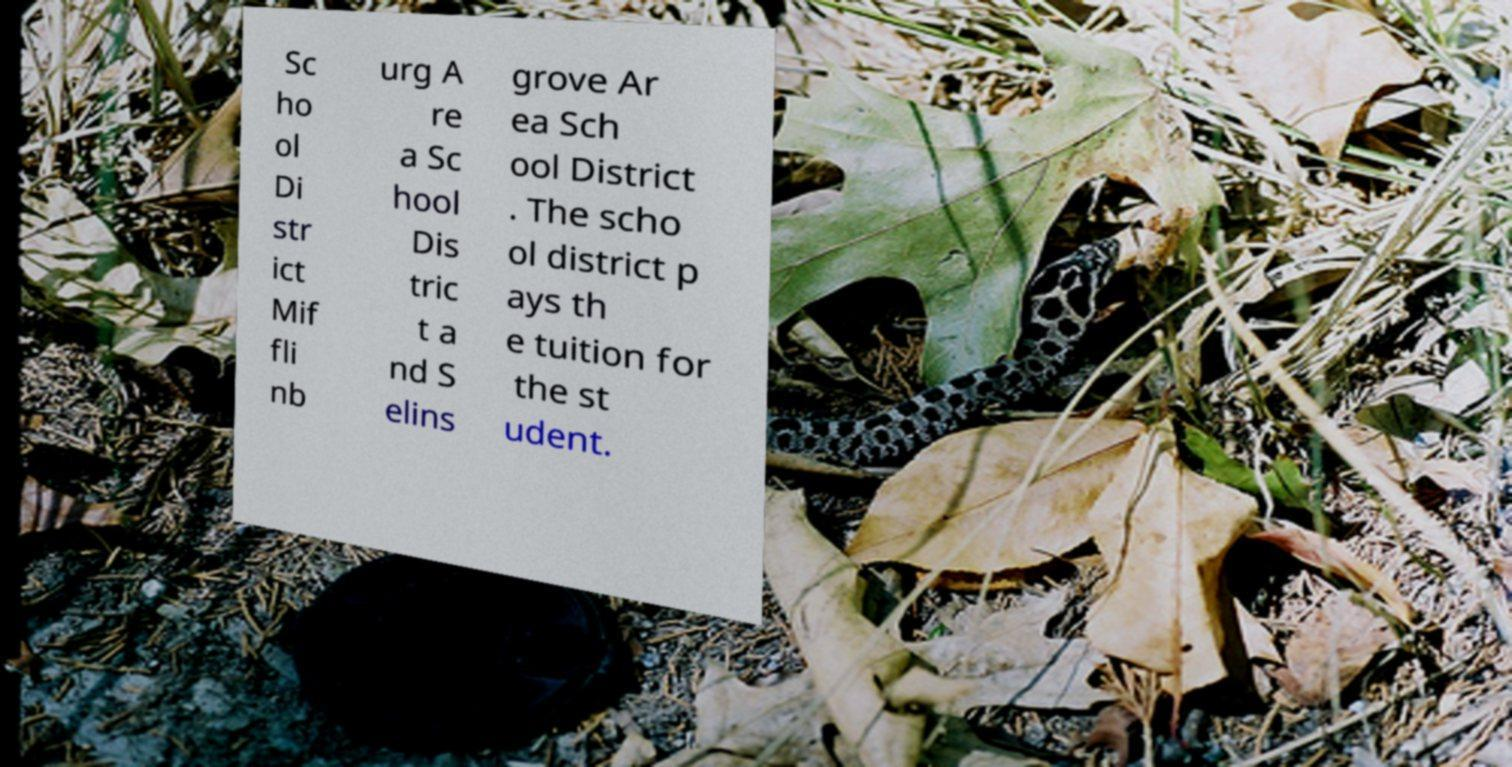For documentation purposes, I need the text within this image transcribed. Could you provide that? Sc ho ol Di str ict Mif fli nb urg A re a Sc hool Dis tric t a nd S elins grove Ar ea Sch ool District . The scho ol district p ays th e tuition for the st udent. 